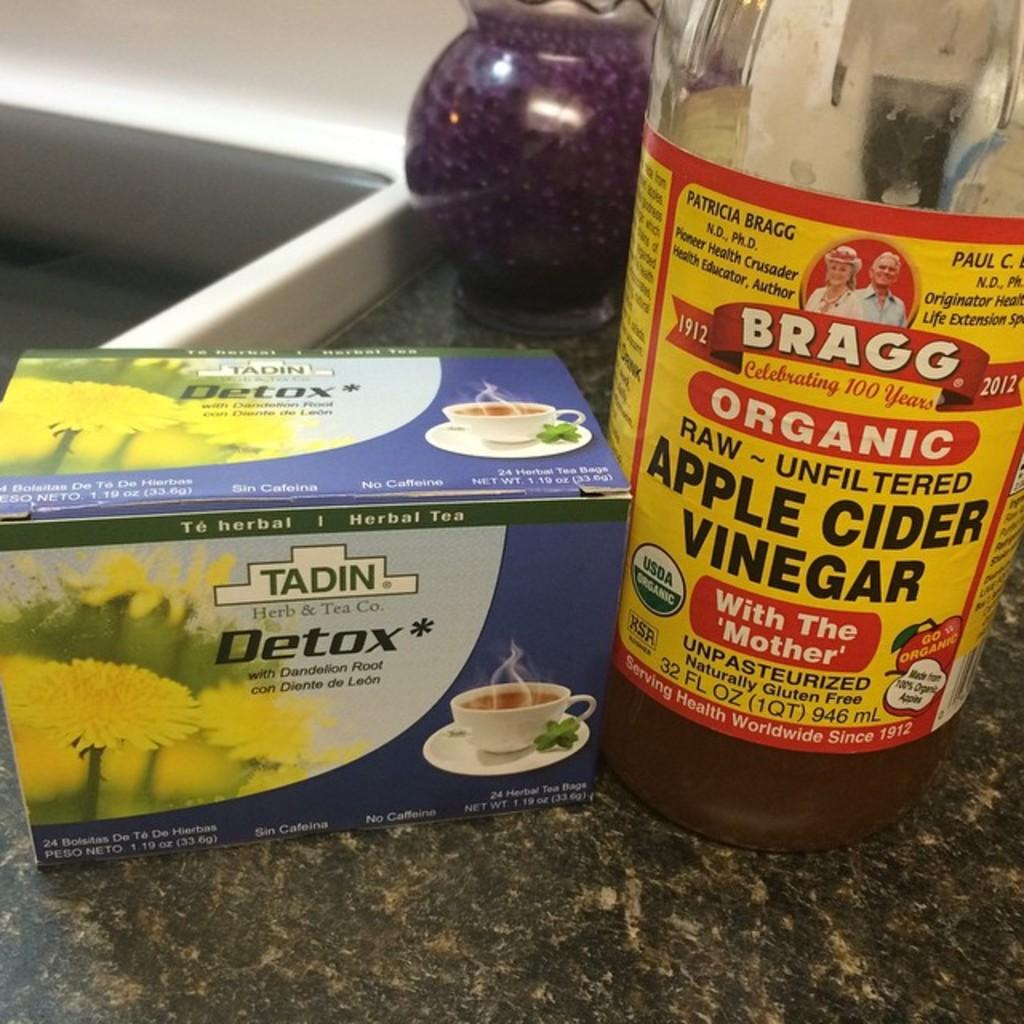What is on the table in the image? There is a box and a bottle on the table in the image. What can be seen on the bottle? The bottle has a label on it. Is there anything else on the bottle besides the label? Yes, there is an object on the bottle. What type of verse is written on the box in the image? There is no verse present on the box in the image. What type of produce is stored in the box in the image? There is no produce visible in the image, and the contents of the box are not specified. 